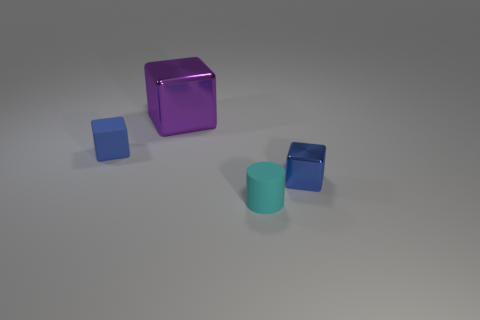Add 2 yellow rubber things. How many objects exist? 6 Subtract all blocks. How many objects are left? 1 Add 3 purple objects. How many purple objects are left? 4 Add 4 big blue blocks. How many big blue blocks exist? 4 Subtract 0 green blocks. How many objects are left? 4 Subtract all rubber cylinders. Subtract all rubber cylinders. How many objects are left? 2 